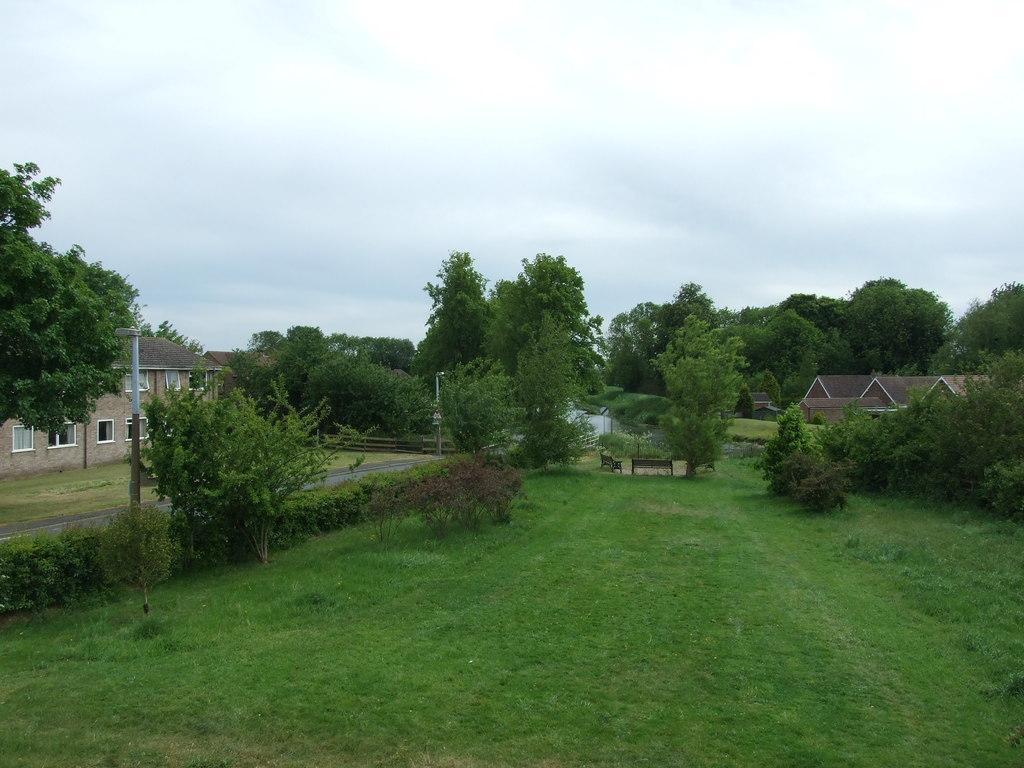What is the main setting of the image? There is a garden in the image. What can be seen in the background of the garden? There are trees and houses in the background of the image. What is visible in the sky in the image? The sky is visible in the background of the image. What type of hook is used to hang the bridge in the image? There is no bridge or hook present in the image. What type of insurance policy is being discussed by the people in the garden in the image? There are no people or discussion about insurance in the image. 